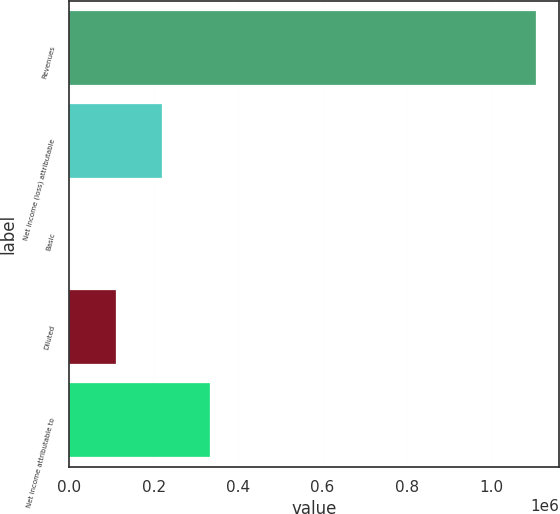<chart> <loc_0><loc_0><loc_500><loc_500><bar_chart><fcel>Revenues<fcel>Net income (loss) attributable<fcel>Basic<fcel>Diluted<fcel>Net income attributable to<nl><fcel>1.10426e+06<fcel>220852<fcel>0.31<fcel>110426<fcel>333044<nl></chart> 